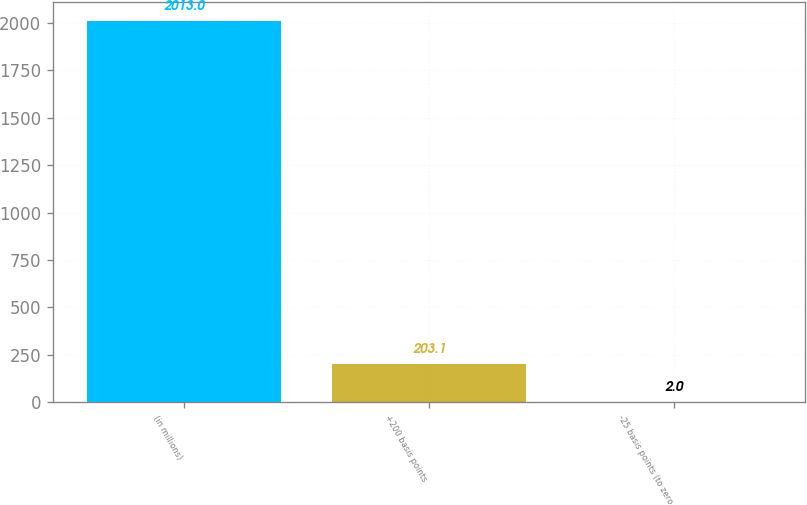<chart> <loc_0><loc_0><loc_500><loc_500><bar_chart><fcel>(in millions)<fcel>+200 basis points<fcel>-25 basis points (to zero<nl><fcel>2013<fcel>203.1<fcel>2<nl></chart> 